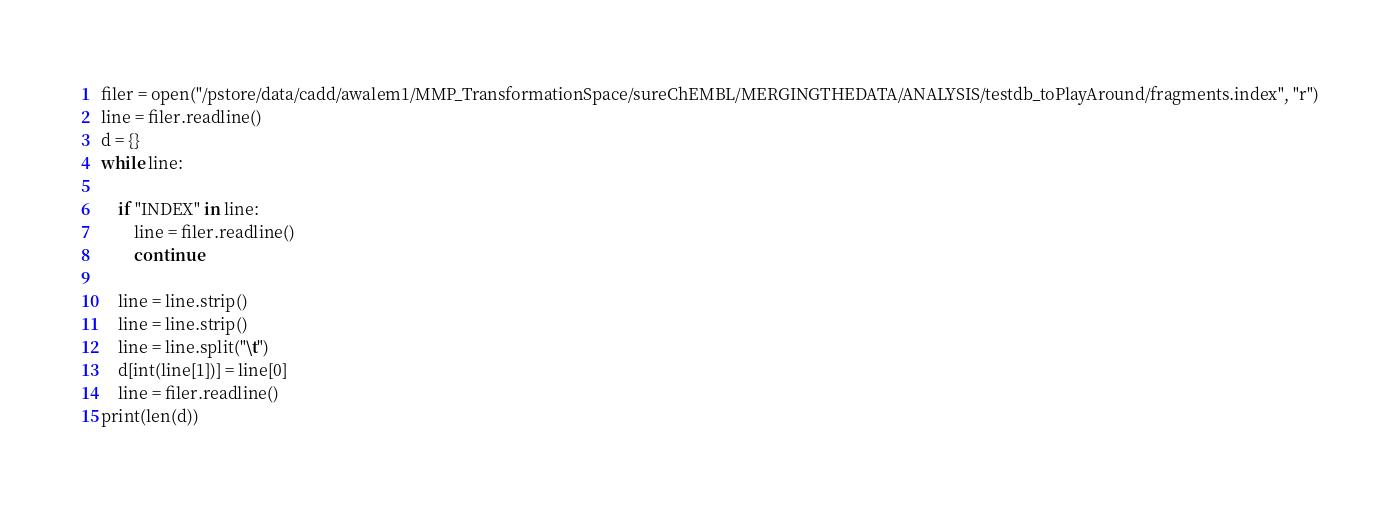Convert code to text. <code><loc_0><loc_0><loc_500><loc_500><_Python_>filer = open("/pstore/data/cadd/awalem1/MMP_TransformationSpace/sureChEMBL/MERGINGTHEDATA/ANALYSIS/testdb_toPlayAround/fragments.index", "r")
line = filer.readline()
d = {}
while line:

    if "INDEX" in line:
        line = filer.readline()
        continue

    line = line.strip()
    line = line.strip()
    line = line.split("\t")
    d[int(line[1])] = line[0]
    line = filer.readline()
print(len(d))</code> 